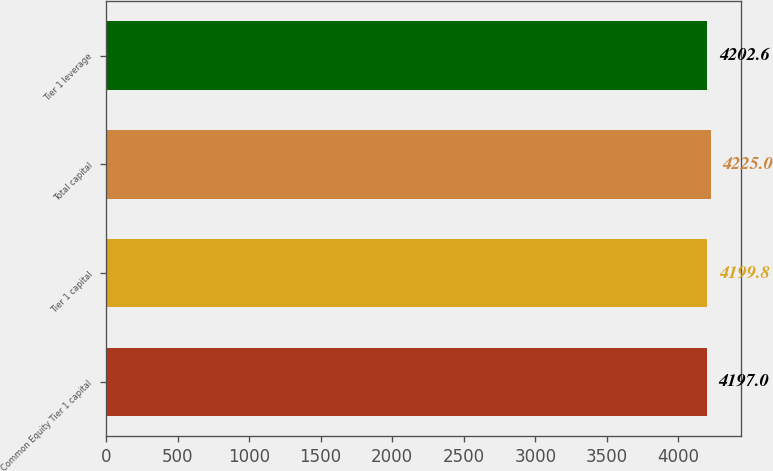Convert chart to OTSL. <chart><loc_0><loc_0><loc_500><loc_500><bar_chart><fcel>Common Equity Tier 1 capital<fcel>Tier 1 capital<fcel>Total capital<fcel>Tier 1 leverage<nl><fcel>4197<fcel>4199.8<fcel>4225<fcel>4202.6<nl></chart> 